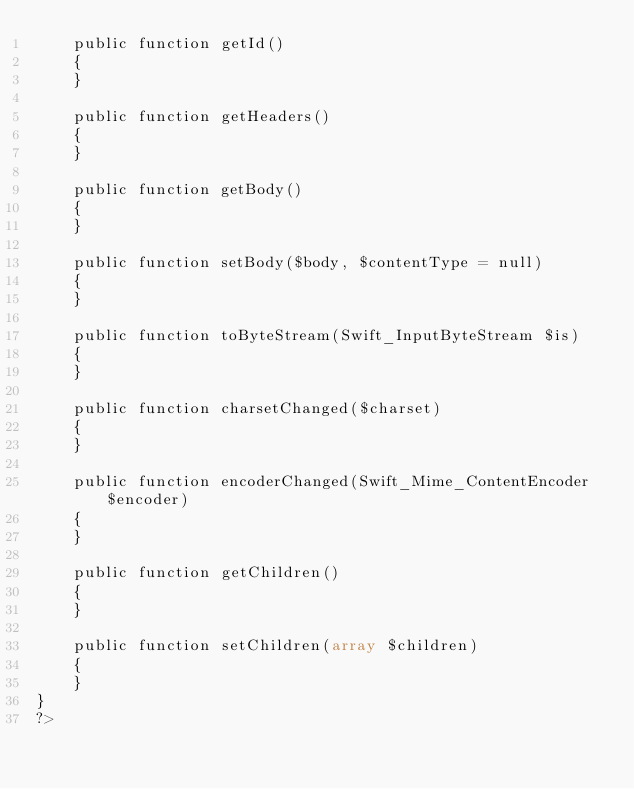Convert code to text. <code><loc_0><loc_0><loc_500><loc_500><_PHP_>    public function getId()
    {
    }

    public function getHeaders()
    {
    }

    public function getBody()
    {
    }

    public function setBody($body, $contentType = null)
    {
    }

    public function toByteStream(Swift_InputByteStream $is)
    {
    }

    public function charsetChanged($charset)
    {
    }

    public function encoderChanged(Swift_Mime_ContentEncoder $encoder)
    {
    }

    public function getChildren()
    {
    }

    public function setChildren(array $children)
    {
    }
}
?></code> 